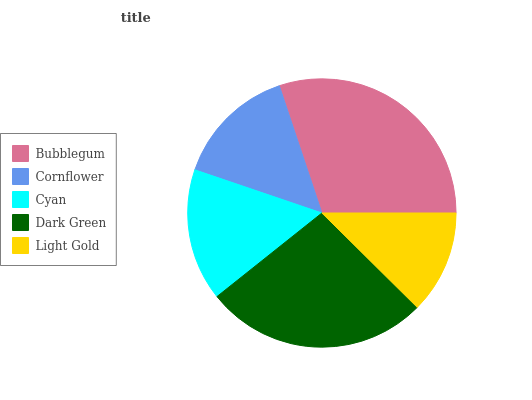Is Light Gold the minimum?
Answer yes or no. Yes. Is Bubblegum the maximum?
Answer yes or no. Yes. Is Cornflower the minimum?
Answer yes or no. No. Is Cornflower the maximum?
Answer yes or no. No. Is Bubblegum greater than Cornflower?
Answer yes or no. Yes. Is Cornflower less than Bubblegum?
Answer yes or no. Yes. Is Cornflower greater than Bubblegum?
Answer yes or no. No. Is Bubblegum less than Cornflower?
Answer yes or no. No. Is Cyan the high median?
Answer yes or no. Yes. Is Cyan the low median?
Answer yes or no. Yes. Is Dark Green the high median?
Answer yes or no. No. Is Dark Green the low median?
Answer yes or no. No. 